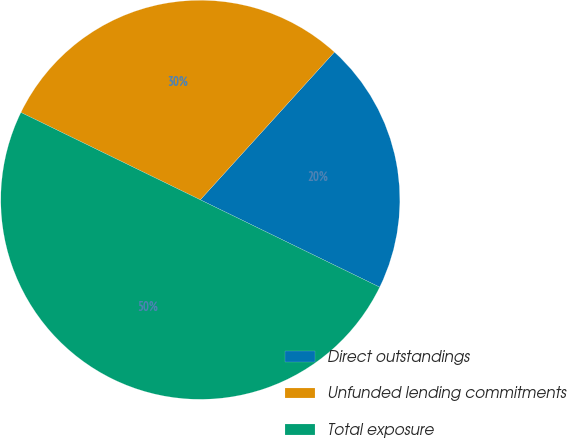Convert chart. <chart><loc_0><loc_0><loc_500><loc_500><pie_chart><fcel>Direct outstandings<fcel>Unfunded lending commitments<fcel>Total exposure<nl><fcel>20.48%<fcel>29.52%<fcel>50.0%<nl></chart> 